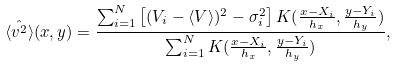<formula> <loc_0><loc_0><loc_500><loc_500>\hat { \langle v ^ { 2 } \rangle } ( x , y ) = \frac { \sum _ { i = 1 } ^ { N } \left [ ( V _ { i } - \langle V \rangle ) ^ { 2 } - \sigma _ { i } ^ { 2 } \right ] K ( \frac { x - X _ { i } } { h _ { x } } , \frac { y - Y _ { i } } { h _ { y } } ) } { \sum _ { i = 1 } ^ { N } K ( \frac { x - X _ { i } } { h _ { x } } , \frac { y - Y _ { i } } { h _ { y } } ) } ,</formula> 